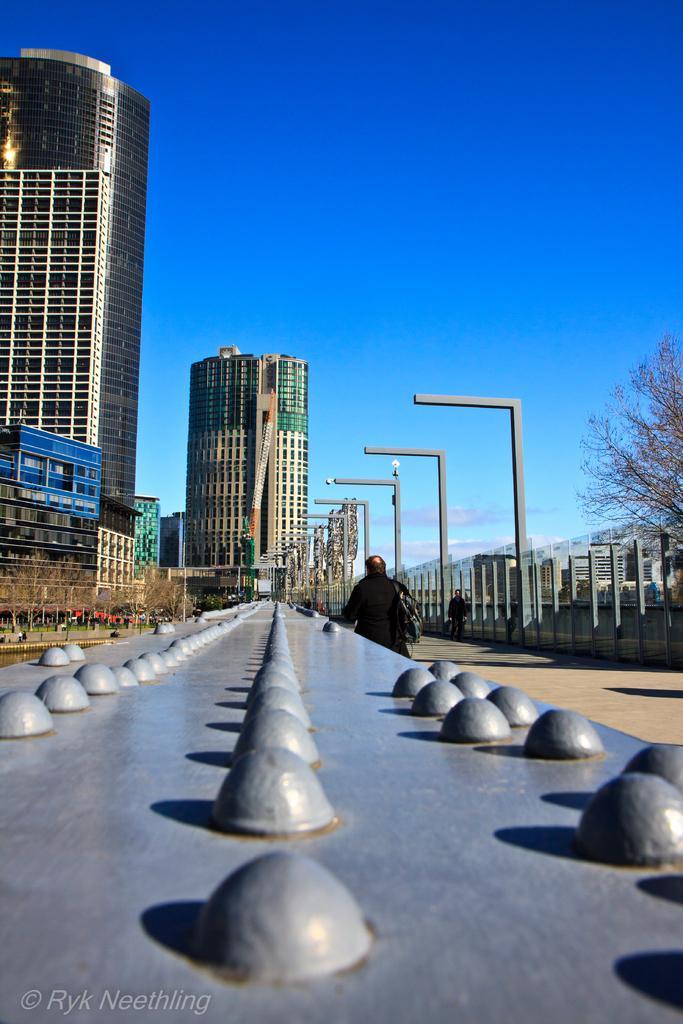In one or two sentences, can you explain what this image depicts? In this image we can see some buildings, poles, lights, some rocks on a surface, there is a person standing, also we can see some trees, and the sky. 